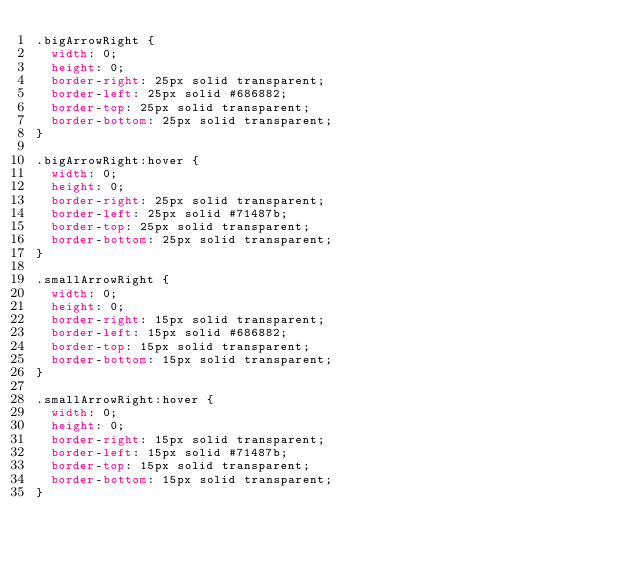<code> <loc_0><loc_0><loc_500><loc_500><_CSS_>.bigArrowRight {
  width: 0;
  height: 0;
  border-right: 25px solid transparent;
  border-left: 25px solid #686882;
  border-top: 25px solid transparent;
  border-bottom: 25px solid transparent;
}

.bigArrowRight:hover {
  width: 0;
  height: 0;
  border-right: 25px solid transparent;
  border-left: 25px solid #71487b;
  border-top: 25px solid transparent;
  border-bottom: 25px solid transparent;
}

.smallArrowRight {
  width: 0;
  height: 0;
  border-right: 15px solid transparent;
  border-left: 15px solid #686882;
  border-top: 15px solid transparent;
  border-bottom: 15px solid transparent;
}

.smallArrowRight:hover {
  width: 0;
  height: 0;
  border-right: 15px solid transparent;
  border-left: 15px solid #71487b;
  border-top: 15px solid transparent;
  border-bottom: 15px solid transparent;
}
</code> 